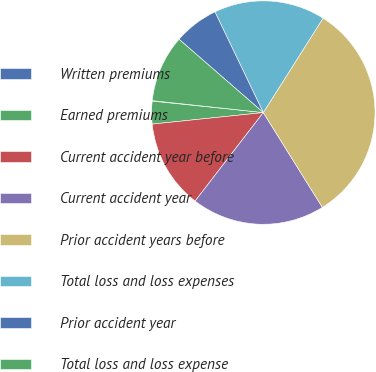<chart> <loc_0><loc_0><loc_500><loc_500><pie_chart><fcel>Written premiums<fcel>Earned premiums<fcel>Current accident year before<fcel>Current accident year<fcel>Prior accident years before<fcel>Total loss and loss expenses<fcel>Prior accident year<fcel>Total loss and loss expense<nl><fcel>0.07%<fcel>3.28%<fcel>12.9%<fcel>19.32%<fcel>32.15%<fcel>16.11%<fcel>6.48%<fcel>9.69%<nl></chart> 